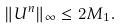<formula> <loc_0><loc_0><loc_500><loc_500>\| U ^ { n } \| _ { \infty } \leq 2 M _ { 1 } .</formula> 